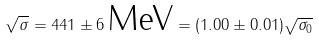<formula> <loc_0><loc_0><loc_500><loc_500>\sqrt { \sigma } = 4 4 1 \pm 6 \, \text {MeV} = ( 1 . 0 0 \pm 0 . 0 1 ) \sqrt { \sigma _ { 0 } }</formula> 